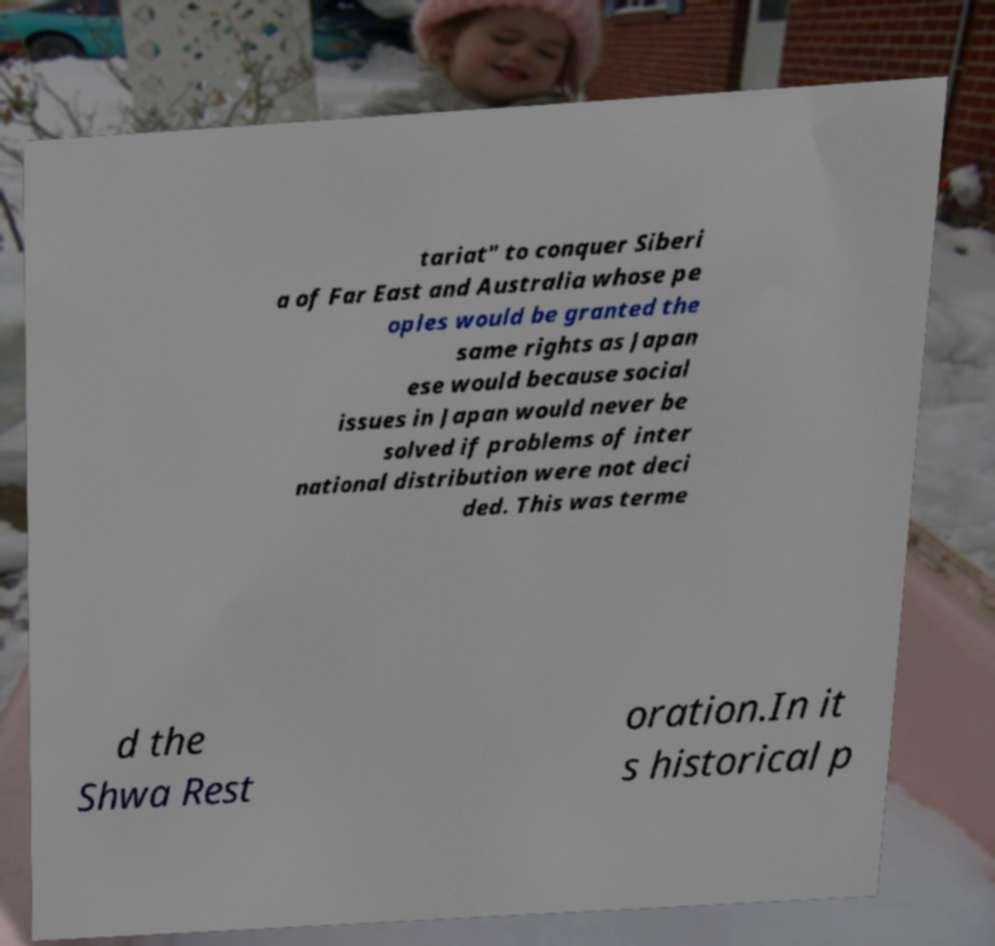Please read and relay the text visible in this image. What does it say? tariat" to conquer Siberi a of Far East and Australia whose pe oples would be granted the same rights as Japan ese would because social issues in Japan would never be solved if problems of inter national distribution were not deci ded. This was terme d the Shwa Rest oration.In it s historical p 